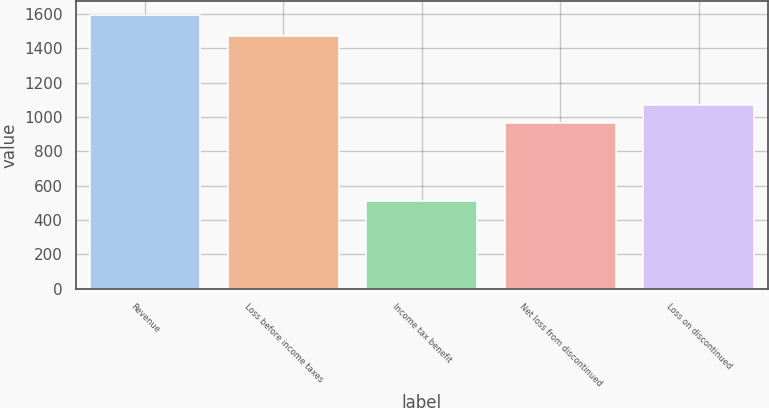<chart> <loc_0><loc_0><loc_500><loc_500><bar_chart><fcel>Revenue<fcel>Loss before income taxes<fcel>Income tax benefit<fcel>Net loss from discontinued<fcel>Loss on discontinued<nl><fcel>1595<fcel>1474<fcel>511<fcel>963<fcel>1071.4<nl></chart> 